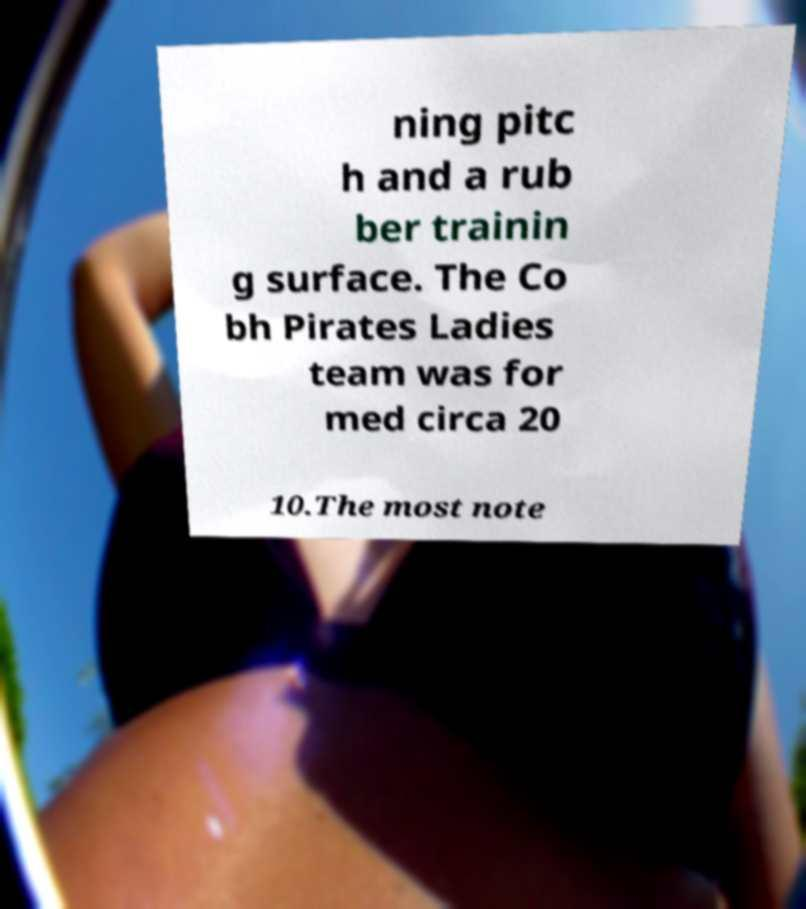Can you read and provide the text displayed in the image?This photo seems to have some interesting text. Can you extract and type it out for me? ning pitc h and a rub ber trainin g surface. The Co bh Pirates Ladies team was for med circa 20 10.The most note 